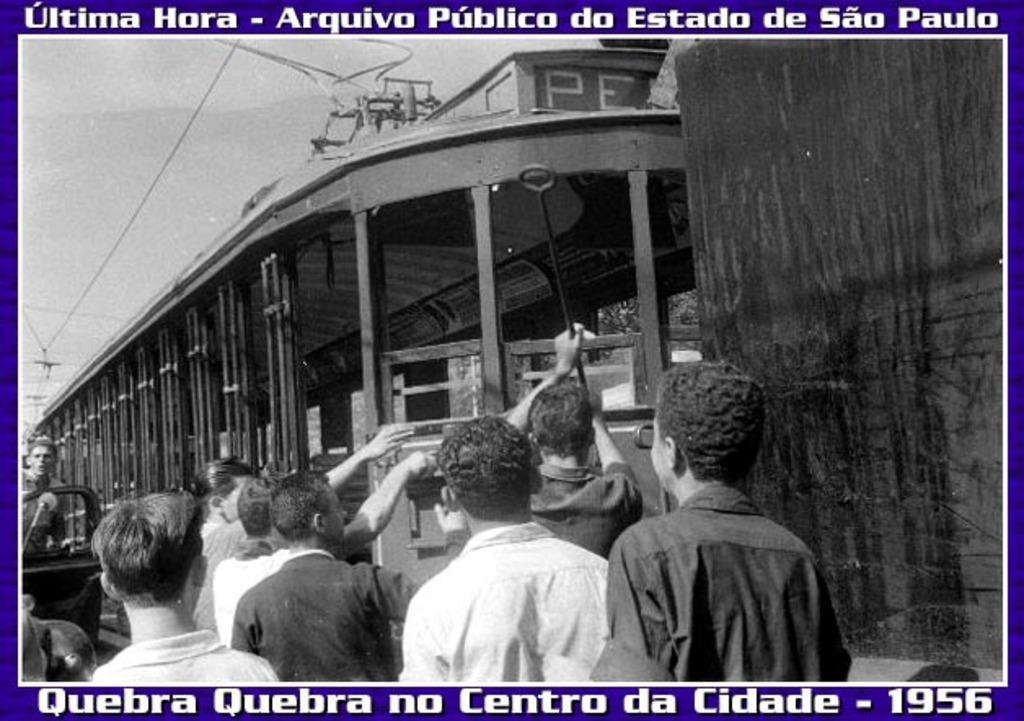What type of picture is in the image? The image contains a black and white picture. What can be seen in the picture? The picture depicts people wearing clothes and a vehicle. Are there any man-made structures visible in the image? Yes, there are electric wires and a metal rod visible in the image. What is visible in the background of the image? The sky is visible in the image. Can you tell me how many tanks are visible in the river in the image? There are no tanks or rivers present in the image. What type of quarter is depicted in the image? There is no quarter depicted in the image; it contains a black and white picture with people, clothes, a vehicle, electric wires, a metal rod, and the sky. 